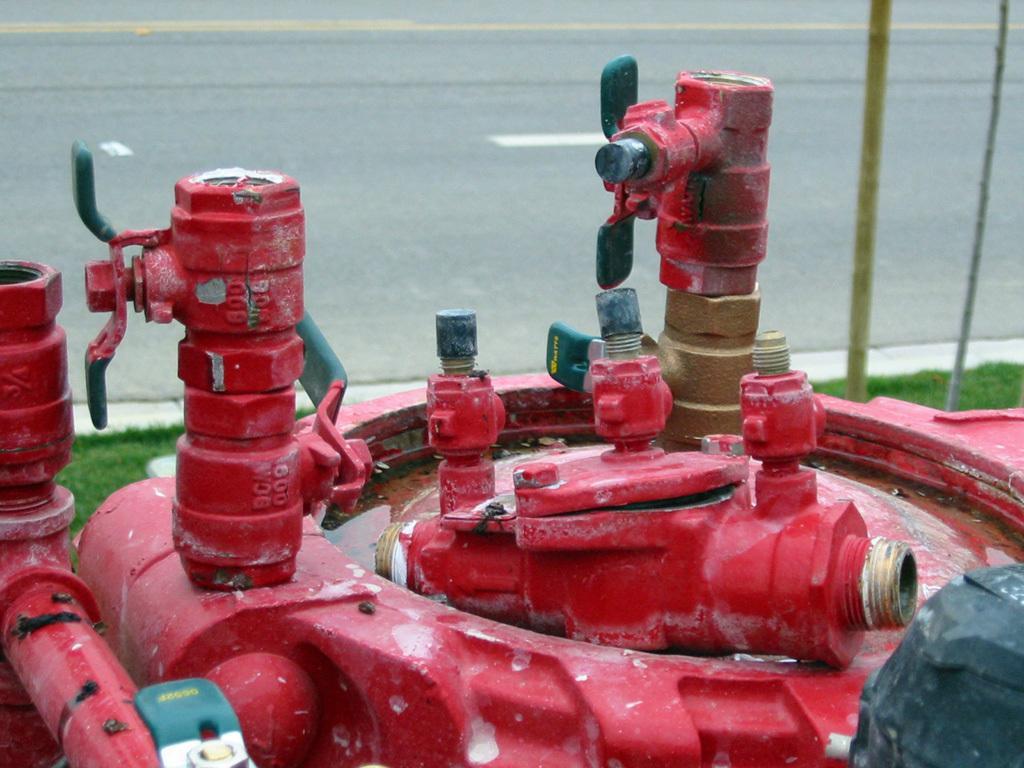Please provide a concise description of this image. In the image to the bottom there are red color water pipes. Behind the water pipes there is a road. 